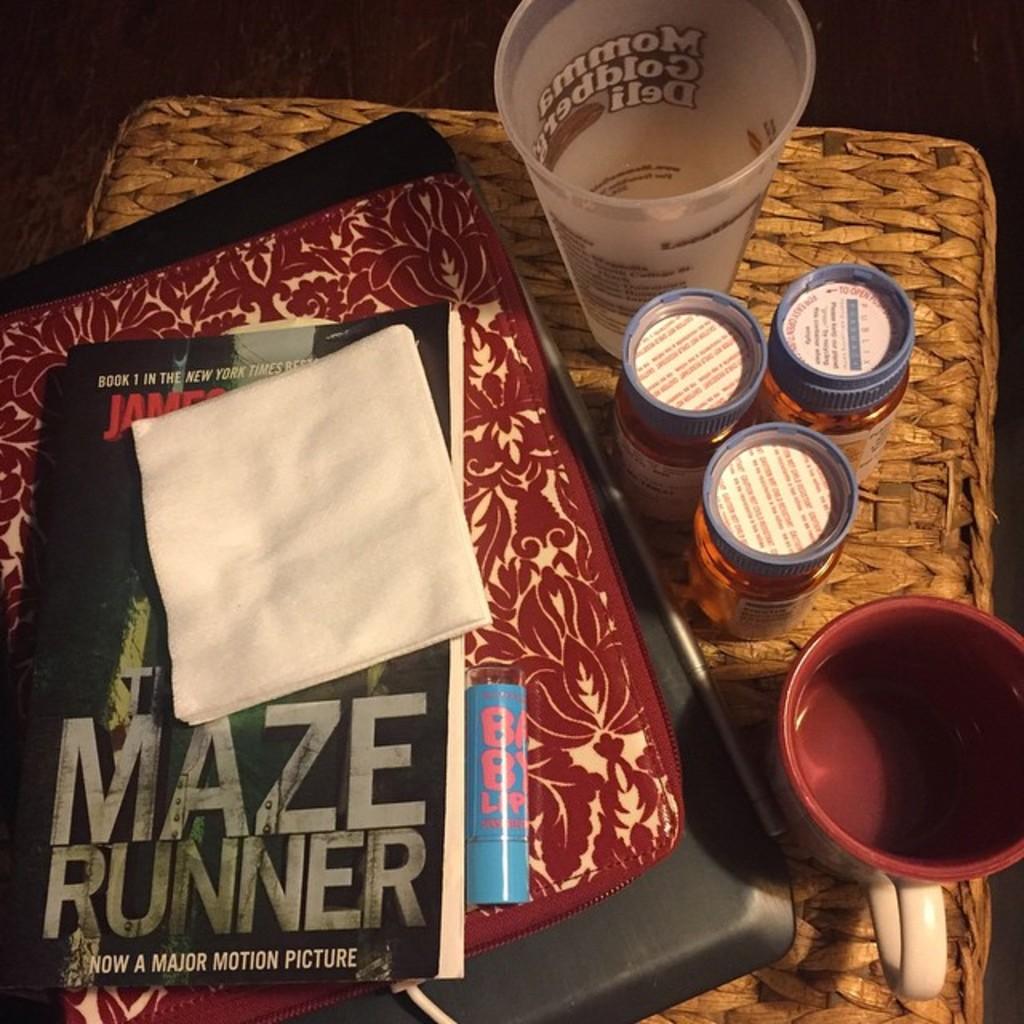What book is that?
Your answer should be very brief. Maze runner. What is the first word on the glass at the top?
Provide a short and direct response. Momma. 